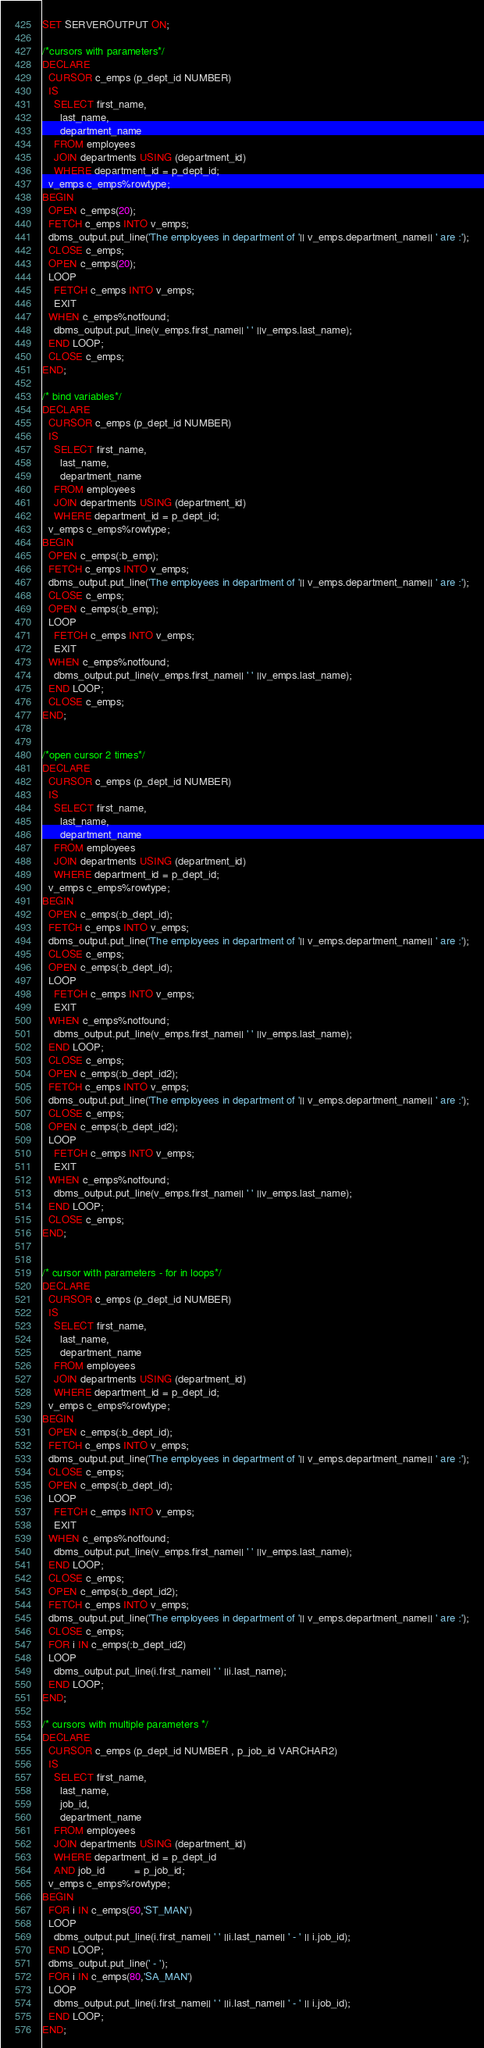<code> <loc_0><loc_0><loc_500><loc_500><_SQL_>SET SERVEROUTPUT ON;

/*cursors with parameters*/
DECLARE
  CURSOR c_emps (p_dept_id NUMBER)
  IS
    SELECT first_name,
      last_name,
      department_name
    FROM employees
    JOIN departments USING (department_id)
    WHERE department_id = p_dept_id;
  v_emps c_emps%rowtype;
BEGIN
  OPEN c_emps(20);
  FETCH c_emps INTO v_emps;
  dbms_output.put_line('The employees in department of '|| v_emps.department_name|| ' are :');
  CLOSE c_emps;
  OPEN c_emps(20);
  LOOP
    FETCH c_emps INTO v_emps;
    EXIT
  WHEN c_emps%notfound;
    dbms_output.put_line(v_emps.first_name|| ' ' ||v_emps.last_name);
  END LOOP;
  CLOSE c_emps;
END;

/* bind variables*/
DECLARE
  CURSOR c_emps (p_dept_id NUMBER)
  IS
    SELECT first_name,
      last_name,
      department_name
    FROM employees
    JOIN departments USING (department_id)
    WHERE department_id = p_dept_id;
  v_emps c_emps%rowtype;
BEGIN
  OPEN c_emps(:b_emp);
  FETCH c_emps INTO v_emps;
  dbms_output.put_line('The employees in department of '|| v_emps.department_name|| ' are :');
  CLOSE c_emps;
  OPEN c_emps(:b_emp);
  LOOP
    FETCH c_emps INTO v_emps;
    EXIT
  WHEN c_emps%notfound;
    dbms_output.put_line(v_emps.first_name|| ' ' ||v_emps.last_name);
  END LOOP;
  CLOSE c_emps;
END;


/*open cursor 2 times*/
DECLARE
  CURSOR c_emps (p_dept_id NUMBER)
  IS
    SELECT first_name,
      last_name,
      department_name
    FROM employees
    JOIN departments USING (department_id)
    WHERE department_id = p_dept_id;
  v_emps c_emps%rowtype;
BEGIN
  OPEN c_emps(:b_dept_id);
  FETCH c_emps INTO v_emps;
  dbms_output.put_line('The employees in department of '|| v_emps.department_name|| ' are :');
  CLOSE c_emps;
  OPEN c_emps(:b_dept_id);
  LOOP
    FETCH c_emps INTO v_emps;
    EXIT
  WHEN c_emps%notfound;
    dbms_output.put_line(v_emps.first_name|| ' ' ||v_emps.last_name);
  END LOOP;
  CLOSE c_emps;
  OPEN c_emps(:b_dept_id2);
  FETCH c_emps INTO v_emps;
  dbms_output.put_line('The employees in department of '|| v_emps.department_name|| ' are :');
  CLOSE c_emps;
  OPEN c_emps(:b_dept_id2);
  LOOP
    FETCH c_emps INTO v_emps;
    EXIT
  WHEN c_emps%notfound;
    dbms_output.put_line(v_emps.first_name|| ' ' ||v_emps.last_name);
  END LOOP;
  CLOSE c_emps;
END;


/* cursor with parameters - for in loops*/
DECLARE
  CURSOR c_emps (p_dept_id NUMBER)
  IS
    SELECT first_name,
      last_name,
      department_name
    FROM employees
    JOIN departments USING (department_id)
    WHERE department_id = p_dept_id;
  v_emps c_emps%rowtype;
BEGIN
  OPEN c_emps(:b_dept_id);
  FETCH c_emps INTO v_emps;
  dbms_output.put_line('The employees in department of '|| v_emps.department_name|| ' are :');
  CLOSE c_emps;
  OPEN c_emps(:b_dept_id);
  LOOP
    FETCH c_emps INTO v_emps;
    EXIT
  WHEN c_emps%notfound;
    dbms_output.put_line(v_emps.first_name|| ' ' ||v_emps.last_name);
  END LOOP;
  CLOSE c_emps;
  OPEN c_emps(:b_dept_id2);
  FETCH c_emps INTO v_emps;
  dbms_output.put_line('The employees in department of '|| v_emps.department_name|| ' are :');
  CLOSE c_emps;
  FOR i IN c_emps(:b_dept_id2)
  LOOP
    dbms_output.put_line(i.first_name|| ' ' ||i.last_name);
  END LOOP;
END;

/* cursors with multiple parameters */
DECLARE
  CURSOR c_emps (p_dept_id NUMBER , p_job_id VARCHAR2)
  IS
    SELECT first_name,
      last_name,
      job_id,
      department_name
    FROM employees
    JOIN departments USING (department_id)
    WHERE department_id = p_dept_id
    AND job_id          = p_job_id;
  v_emps c_emps%rowtype;
BEGIN
  FOR i IN c_emps(50,'ST_MAN')
  LOOP
    dbms_output.put_line(i.first_name|| ' ' ||i.last_name|| ' - ' || i.job_id);
  END LOOP;
  dbms_output.put_line(' - ');
  FOR i IN c_emps(80,'SA_MAN')
  LOOP
    dbms_output.put_line(i.first_name|| ' ' ||i.last_name|| ' - ' || i.job_id);
  END LOOP;
END;</code> 